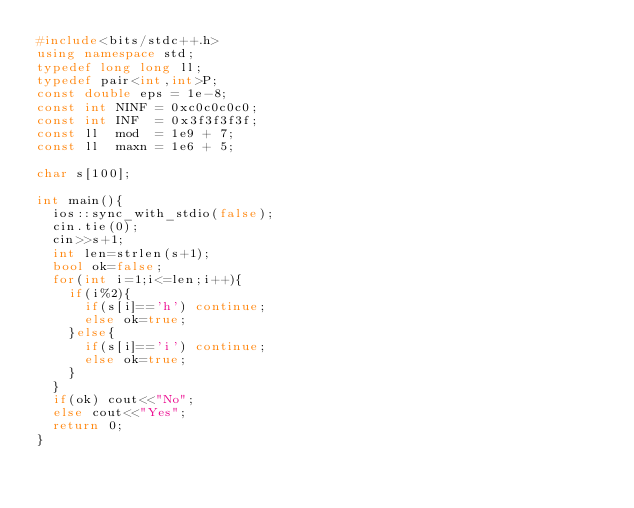Convert code to text. <code><loc_0><loc_0><loc_500><loc_500><_C++_>#include<bits/stdc++.h>
using namespace std;
typedef long long ll;
typedef pair<int,int>P;
const double eps = 1e-8;
const int NINF = 0xc0c0c0c0;
const int INF  = 0x3f3f3f3f;
const ll  mod  = 1e9 + 7;
const ll  maxn = 1e6 + 5;

char s[100];

int main(){
	ios::sync_with_stdio(false);
	cin.tie(0);
	cin>>s+1;
	int len=strlen(s+1);
	bool ok=false;
	for(int i=1;i<=len;i++){
		if(i%2){
			if(s[i]=='h') continue;
			else ok=true;
		}else{
			if(s[i]=='i') continue;
			else ok=true;
		}
	}
	if(ok) cout<<"No";
	else cout<<"Yes";
	return 0;
}</code> 